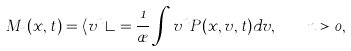Convert formula to latex. <formula><loc_0><loc_0><loc_500><loc_500>M _ { n } ( x , t ) = \langle v ^ { n } \rangle = \frac { 1 } { \rho } \int v ^ { n } P ( x , v , t ) d v , \quad n > 0 ,</formula> 